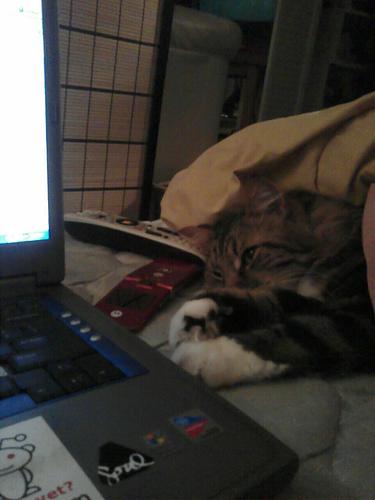Is the cat outdoors?
Be succinct. No. What is the cat doing?
Concise answer only. Resting. What is the remote control for?
Short answer required. Tv. What is the cat laying on?
Quick response, please. Couch. What kind of electronics is in the picture?
Answer briefly. Laptop. Are there stickers on the laptop?
Write a very short answer. Yes. 